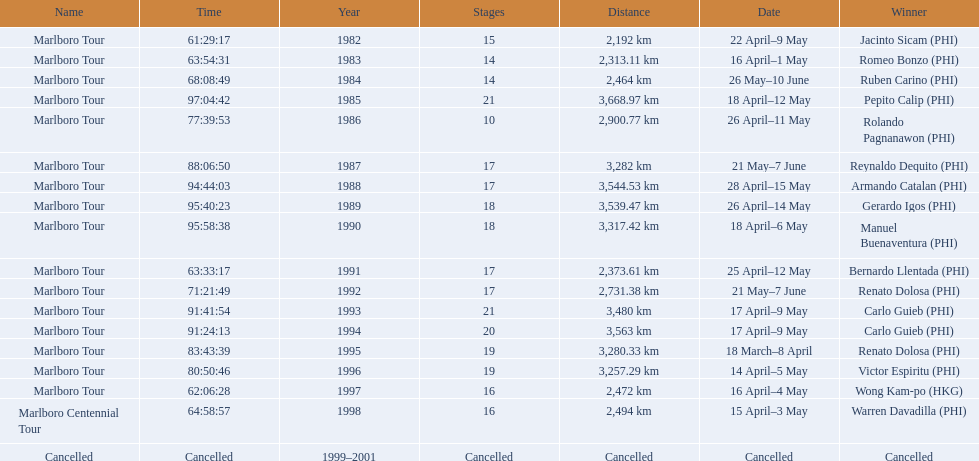Which year did warren davdilla (w.d.) appear? 1998. What tour did w.d. complete? Marlboro Centennial Tour. What is the time recorded in the same row as w.d.? 64:58:57. 